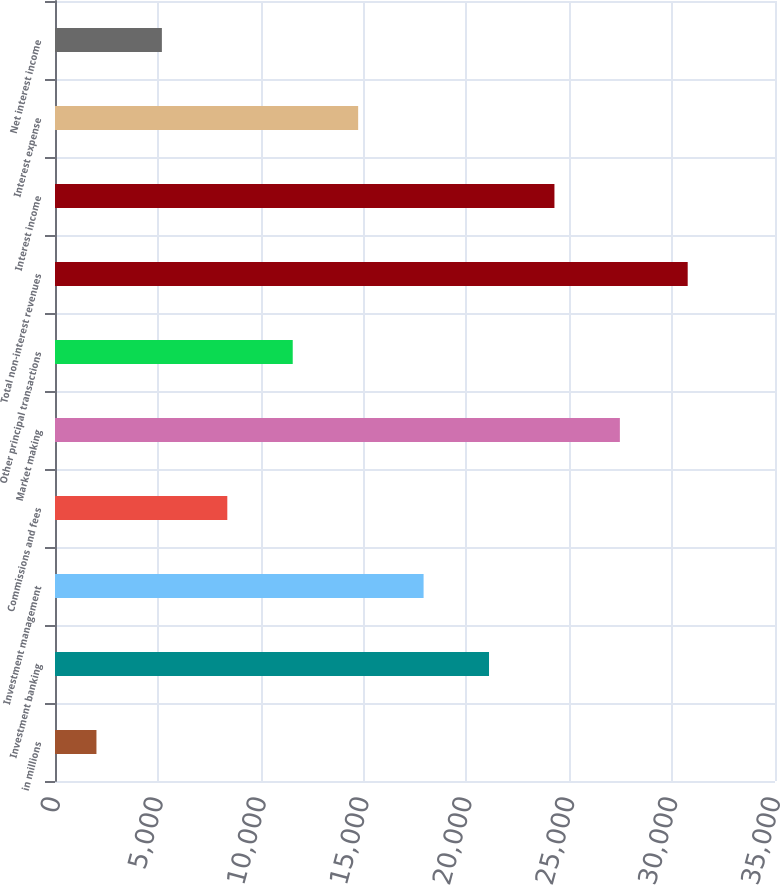Convert chart to OTSL. <chart><loc_0><loc_0><loc_500><loc_500><bar_chart><fcel>in millions<fcel>Investment banking<fcel>Investment management<fcel>Commissions and fees<fcel>Market making<fcel>Other principal transactions<fcel>Total non-interest revenues<fcel>Interest income<fcel>Interest expense<fcel>Net interest income<nl><fcel>2015<fcel>21098<fcel>17917.5<fcel>8376<fcel>27459<fcel>11556.5<fcel>30756<fcel>24278.5<fcel>14737<fcel>5195.5<nl></chart> 